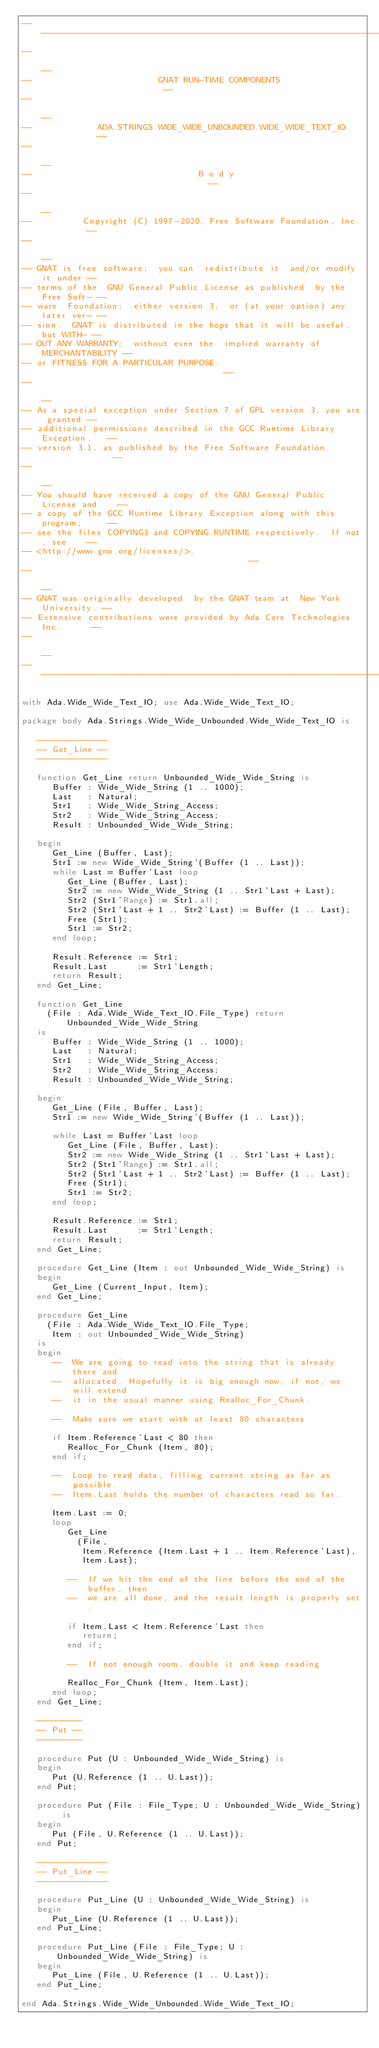<code> <loc_0><loc_0><loc_500><loc_500><_Ada_>------------------------------------------------------------------------------
--                                                                          --
--                         GNAT RUN-TIME COMPONENTS                         --
--                                                                          --
--             ADA.STRINGS.WIDE_WIDE_UNBOUNDED.WIDE_WIDE_TEXT_IO            --
--                                                                          --
--                                 B o d y                                  --
--                                                                          --
--          Copyright (C) 1997-2020, Free Software Foundation, Inc.         --
--                                                                          --
-- GNAT is free software;  you can  redistribute it  and/or modify it under --
-- terms of the  GNU General Public License as published  by the Free Soft- --
-- ware  Foundation;  either version 3,  or (at your option) any later ver- --
-- sion.  GNAT is distributed in the hope that it will be useful, but WITH- --
-- OUT ANY WARRANTY;  without even the  implied warranty of MERCHANTABILITY --
-- or FITNESS FOR A PARTICULAR PURPOSE.                                     --
--                                                                          --
-- As a special exception under Section 7 of GPL version 3, you are granted --
-- additional permissions described in the GCC Runtime Library Exception,   --
-- version 3.1, as published by the Free Software Foundation.               --
--                                                                          --
-- You should have received a copy of the GNU General Public License and    --
-- a copy of the GCC Runtime Library Exception along with this program;     --
-- see the files COPYING3 and COPYING.RUNTIME respectively.  If not, see    --
-- <http://www.gnu.org/licenses/>.                                          --
--                                                                          --
-- GNAT was originally developed  by the GNAT team at  New York University. --
-- Extensive contributions were provided by Ada Core Technologies Inc.      --
--                                                                          --
------------------------------------------------------------------------------

with Ada.Wide_Wide_Text_IO; use Ada.Wide_Wide_Text_IO;

package body Ada.Strings.Wide_Wide_Unbounded.Wide_Wide_Text_IO is

   --------------
   -- Get_Line --
   --------------

   function Get_Line return Unbounded_Wide_Wide_String is
      Buffer : Wide_Wide_String (1 .. 1000);
      Last   : Natural;
      Str1   : Wide_Wide_String_Access;
      Str2   : Wide_Wide_String_Access;
      Result : Unbounded_Wide_Wide_String;

   begin
      Get_Line (Buffer, Last);
      Str1 := new Wide_Wide_String'(Buffer (1 .. Last));
      while Last = Buffer'Last loop
         Get_Line (Buffer, Last);
         Str2 := new Wide_Wide_String (1 .. Str1'Last + Last);
         Str2 (Str1'Range) := Str1.all;
         Str2 (Str1'Last + 1 .. Str2'Last) := Buffer (1 .. Last);
         Free (Str1);
         Str1 := Str2;
      end loop;

      Result.Reference := Str1;
      Result.Last      := Str1'Length;
      return Result;
   end Get_Line;

   function Get_Line
     (File : Ada.Wide_Wide_Text_IO.File_Type) return Unbounded_Wide_Wide_String
   is
      Buffer : Wide_Wide_String (1 .. 1000);
      Last   : Natural;
      Str1   : Wide_Wide_String_Access;
      Str2   : Wide_Wide_String_Access;
      Result : Unbounded_Wide_Wide_String;

   begin
      Get_Line (File, Buffer, Last);
      Str1 := new Wide_Wide_String'(Buffer (1 .. Last));

      while Last = Buffer'Last loop
         Get_Line (File, Buffer, Last);
         Str2 := new Wide_Wide_String (1 .. Str1'Last + Last);
         Str2 (Str1'Range) := Str1.all;
         Str2 (Str1'Last + 1 .. Str2'Last) := Buffer (1 .. Last);
         Free (Str1);
         Str1 := Str2;
      end loop;

      Result.Reference := Str1;
      Result.Last      := Str1'Length;
      return Result;
   end Get_Line;

   procedure Get_Line (Item : out Unbounded_Wide_Wide_String) is
   begin
      Get_Line (Current_Input, Item);
   end Get_Line;

   procedure Get_Line
     (File : Ada.Wide_Wide_Text_IO.File_Type;
      Item : out Unbounded_Wide_Wide_String)
   is
   begin
      --  We are going to read into the string that is already there and
      --  allocated. Hopefully it is big enough now, if not, we will extend
      --  it in the usual manner using Realloc_For_Chunk.

      --  Make sure we start with at least 80 characters

      if Item.Reference'Last < 80 then
         Realloc_For_Chunk (Item, 80);
      end if;

      --  Loop to read data, filling current string as far as possible.
      --  Item.Last holds the number of characters read so far.

      Item.Last := 0;
      loop
         Get_Line
           (File,
            Item.Reference (Item.Last + 1 .. Item.Reference'Last),
            Item.Last);

         --  If we hit the end of the line before the end of the buffer, then
         --  we are all done, and the result length is properly set.

         if Item.Last < Item.Reference'Last then
            return;
         end if;

         --  If not enough room, double it and keep reading

         Realloc_For_Chunk (Item, Item.Last);
      end loop;
   end Get_Line;

   ---------
   -- Put --
   ---------

   procedure Put (U : Unbounded_Wide_Wide_String) is
   begin
      Put (U.Reference (1 .. U.Last));
   end Put;

   procedure Put (File : File_Type; U : Unbounded_Wide_Wide_String) is
   begin
      Put (File, U.Reference (1 .. U.Last));
   end Put;

   --------------
   -- Put_Line --
   --------------

   procedure Put_Line (U : Unbounded_Wide_Wide_String) is
   begin
      Put_Line (U.Reference (1 .. U.Last));
   end Put_Line;

   procedure Put_Line (File : File_Type; U : Unbounded_Wide_Wide_String) is
   begin
      Put_Line (File, U.Reference (1 .. U.Last));
   end Put_Line;

end Ada.Strings.Wide_Wide_Unbounded.Wide_Wide_Text_IO;
</code> 